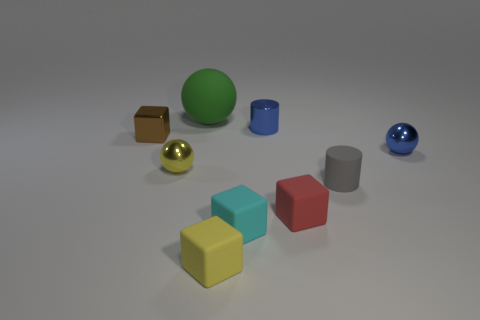There is another metal thing that is the same shape as the cyan object; what is its color?
Give a very brief answer. Brown. The cylinder that is made of the same material as the yellow block is what color?
Your answer should be compact. Gray. Are the tiny gray cylinder and the small sphere that is to the left of the tiny yellow cube made of the same material?
Make the answer very short. No. What number of tiny cyan blocks are the same material as the gray cylinder?
Make the answer very short. 1. The tiny thing that is to the left of the yellow sphere has what shape?
Offer a very short reply. Cube. Is the small cyan cube right of the tiny brown thing made of the same material as the small blue object that is left of the small red rubber thing?
Your answer should be compact. No. Is there a large blue thing that has the same shape as the gray thing?
Your response must be concise. No. How many objects are cubes on the right side of the rubber ball or small shiny things?
Ensure brevity in your answer.  7. Is the number of shiny spheres that are right of the matte cylinder greater than the number of gray rubber cylinders on the left side of the tiny cyan matte cube?
Provide a succinct answer. Yes. How many metal objects are either blue spheres or yellow spheres?
Your answer should be very brief. 2. 